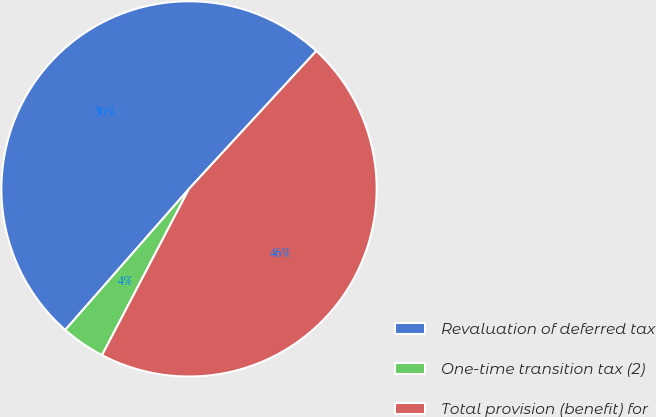Convert chart to OTSL. <chart><loc_0><loc_0><loc_500><loc_500><pie_chart><fcel>Revaluation of deferred tax<fcel>One-time transition tax (2)<fcel>Total provision (benefit) for<nl><fcel>50.4%<fcel>3.79%<fcel>45.81%<nl></chart> 